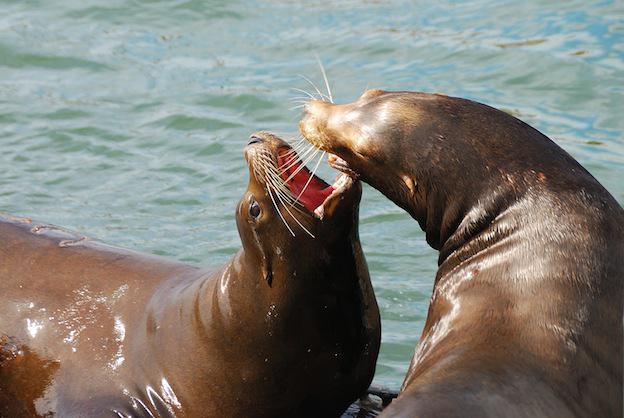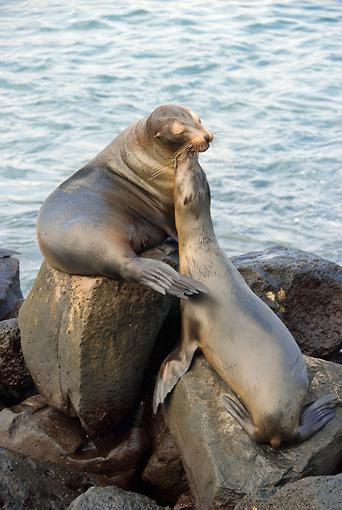The first image is the image on the left, the second image is the image on the right. For the images shown, is this caption "The right image contains exactly two seals." true? Answer yes or no. Yes. The first image is the image on the left, the second image is the image on the right. For the images shown, is this caption "The left and right image contains the same number of sea lions." true? Answer yes or no. Yes. 